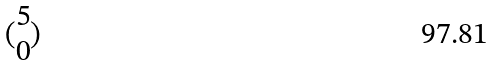<formula> <loc_0><loc_0><loc_500><loc_500>( \begin{matrix} 5 \\ 0 \end{matrix} )</formula> 